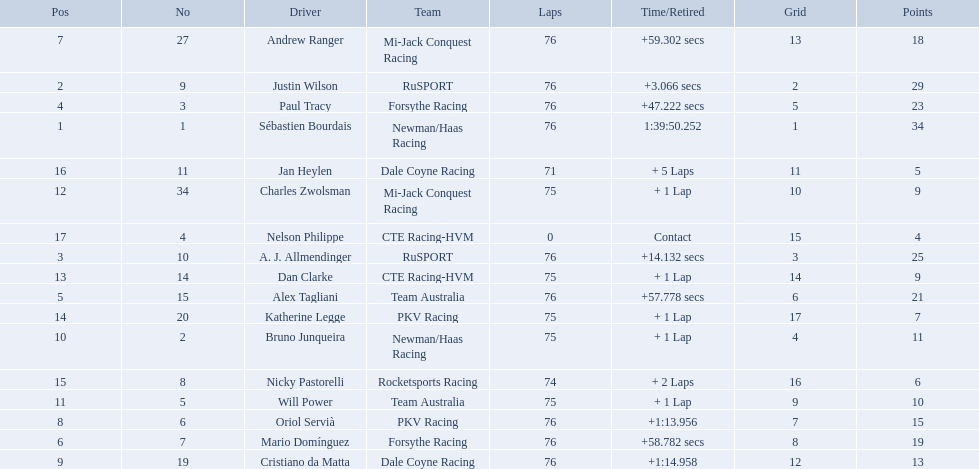What drivers took part in the 2006 tecate grand prix of monterrey? Sébastien Bourdais, Justin Wilson, A. J. Allmendinger, Paul Tracy, Alex Tagliani, Mario Domínguez, Andrew Ranger, Oriol Servià, Cristiano da Matta, Bruno Junqueira, Will Power, Charles Zwolsman, Dan Clarke, Katherine Legge, Nicky Pastorelli, Jan Heylen, Nelson Philippe. Which of those drivers scored the same amount of points as another driver? Charles Zwolsman, Dan Clarke. Who had the same amount of points as charles zwolsman? Dan Clarke. 